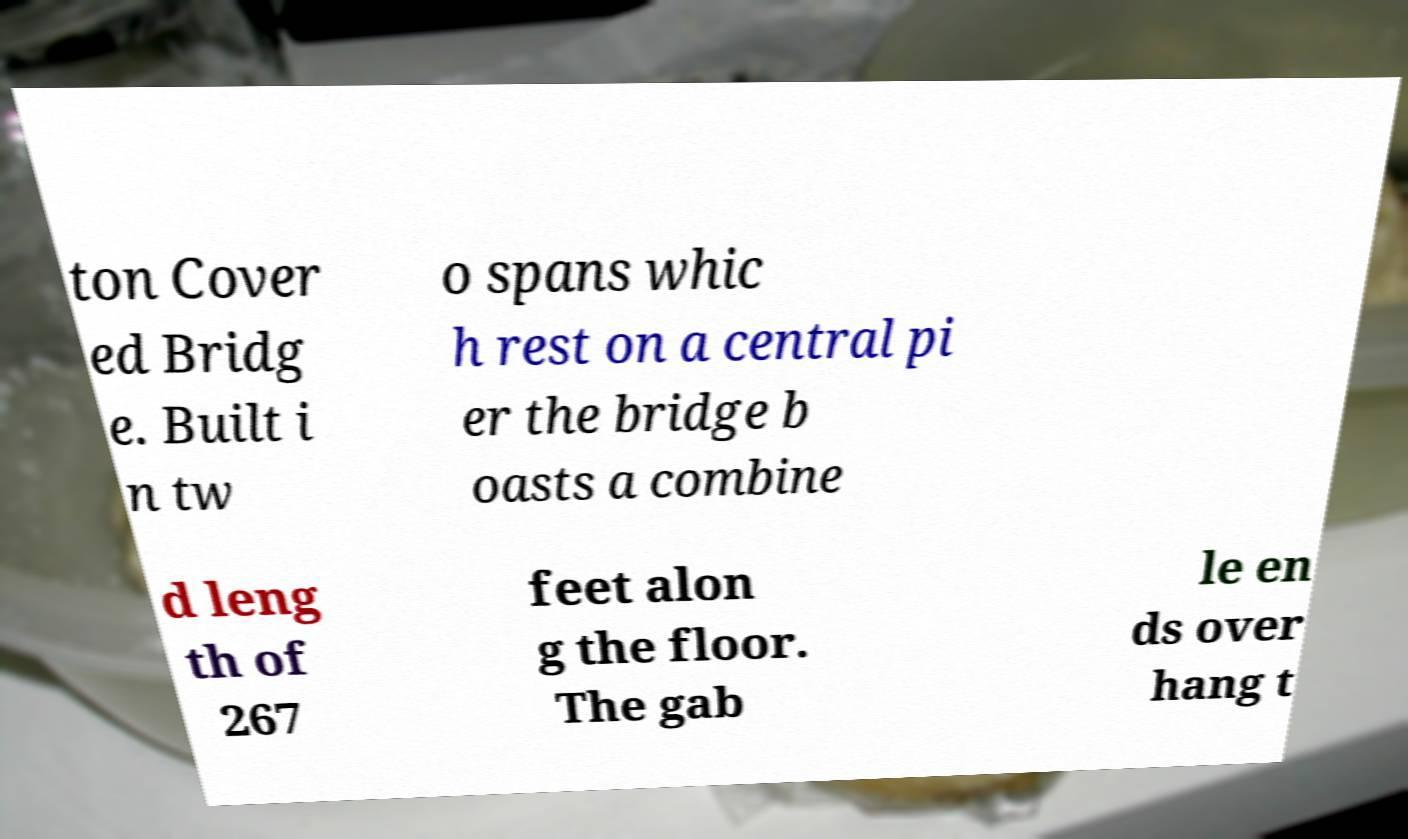What messages or text are displayed in this image? I need them in a readable, typed format. ton Cover ed Bridg e. Built i n tw o spans whic h rest on a central pi er the bridge b oasts a combine d leng th of 267 feet alon g the floor. The gab le en ds over hang t 